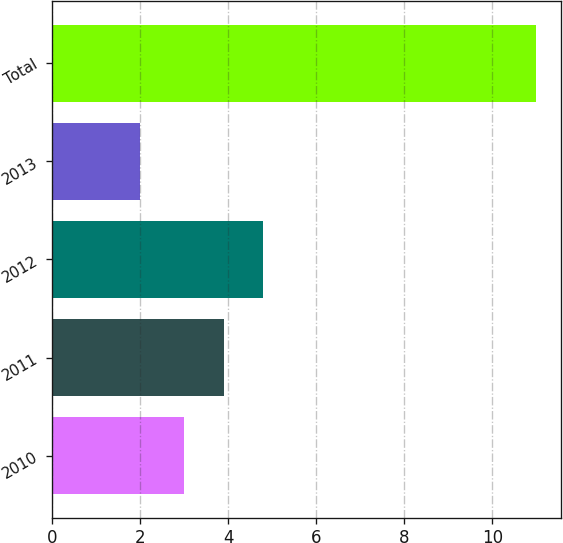Convert chart. <chart><loc_0><loc_0><loc_500><loc_500><bar_chart><fcel>2010<fcel>2011<fcel>2012<fcel>2013<fcel>Total<nl><fcel>3<fcel>3.9<fcel>4.8<fcel>2<fcel>11<nl></chart> 